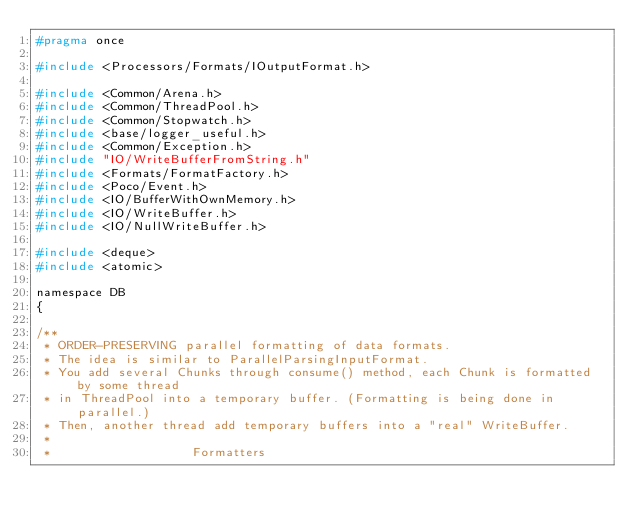<code> <loc_0><loc_0><loc_500><loc_500><_C_>#pragma once

#include <Processors/Formats/IOutputFormat.h>

#include <Common/Arena.h>
#include <Common/ThreadPool.h>
#include <Common/Stopwatch.h>
#include <base/logger_useful.h>
#include <Common/Exception.h>
#include "IO/WriteBufferFromString.h"
#include <Formats/FormatFactory.h>
#include <Poco/Event.h>
#include <IO/BufferWithOwnMemory.h>
#include <IO/WriteBuffer.h>
#include <IO/NullWriteBuffer.h>

#include <deque>
#include <atomic>

namespace DB
{

/**
 * ORDER-PRESERVING parallel formatting of data formats.
 * The idea is similar to ParallelParsingInputFormat.
 * You add several Chunks through consume() method, each Chunk is formatted by some thread
 * in ThreadPool into a temporary buffer. (Formatting is being done in parallel.)
 * Then, another thread add temporary buffers into a "real" WriteBuffer.
 *
 *                   Formatters</code> 